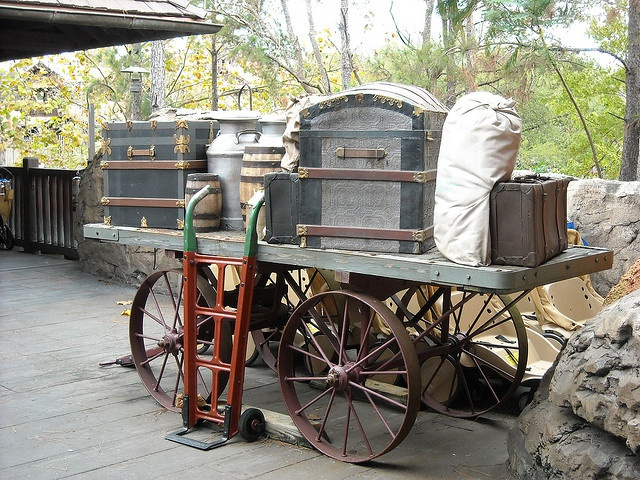Describe the objects in this image and their specific colors. I can see suitcase in black and gray tones, suitcase in black, gray, and maroon tones, and suitcase in black, gray, purple, and darkgray tones in this image. 